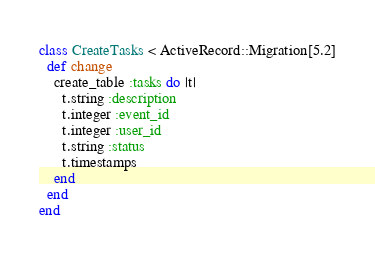<code> <loc_0><loc_0><loc_500><loc_500><_Ruby_>class CreateTasks < ActiveRecord::Migration[5.2]
  def change
    create_table :tasks do |t|
      t.string :description
      t.integer :event_id
      t.integer :user_id
      t.string :status
      t.timestamps
    end
  end
end
</code> 